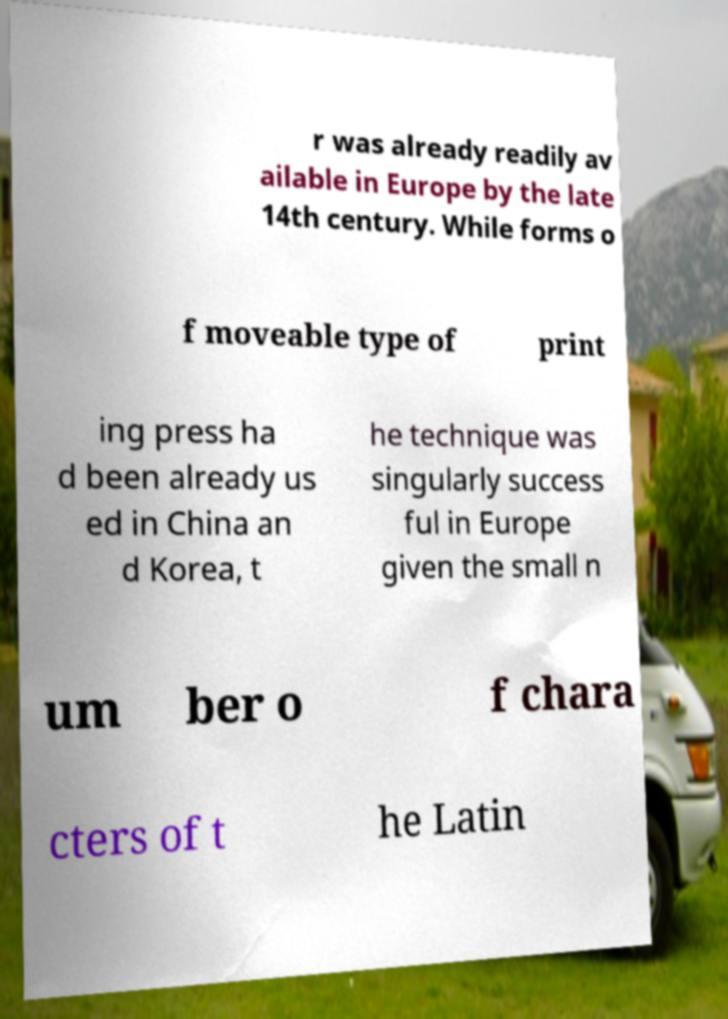Can you read and provide the text displayed in the image?This photo seems to have some interesting text. Can you extract and type it out for me? r was already readily av ailable in Europe by the late 14th century. While forms o f moveable type of print ing press ha d been already us ed in China an d Korea, t he technique was singularly success ful in Europe given the small n um ber o f chara cters of t he Latin 